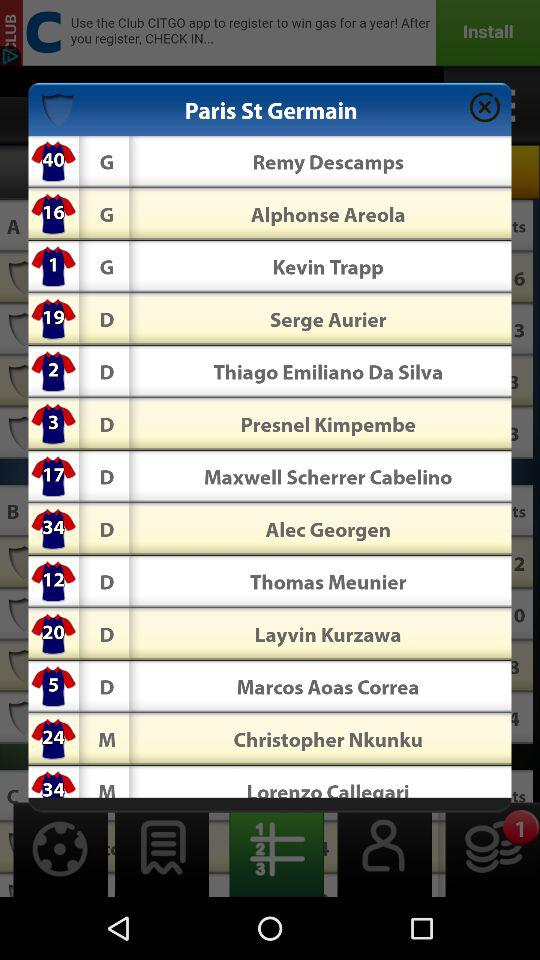How many notifications have been received? There is 1 notification received. 